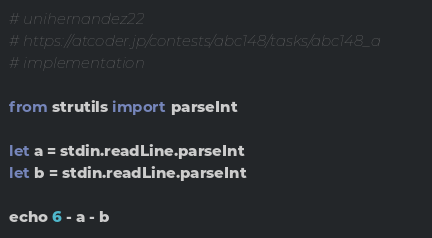Convert code to text. <code><loc_0><loc_0><loc_500><loc_500><_Nim_># unihernandez22
# https://atcoder.jp/contests/abc148/tasks/abc148_a
# implementation

from strutils import parseInt

let a = stdin.readLine.parseInt
let b = stdin.readLine.parseInt

echo 6 - a - b
</code> 